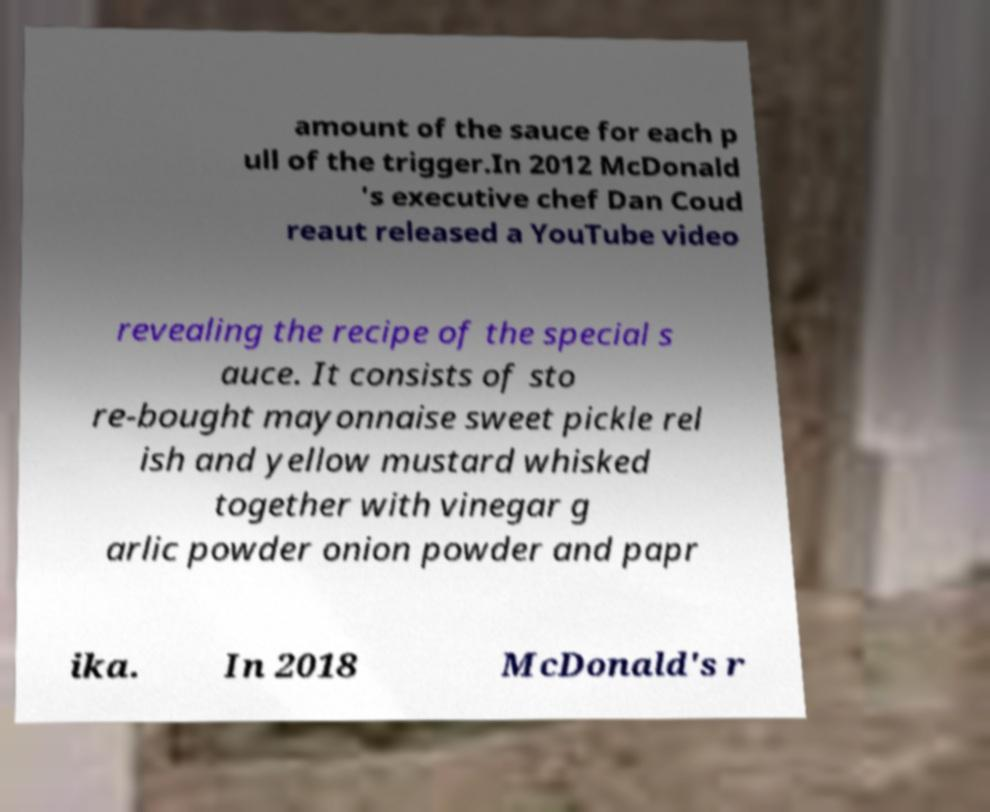Please identify and transcribe the text found in this image. amount of the sauce for each p ull of the trigger.In 2012 McDonald 's executive chef Dan Coud reaut released a YouTube video revealing the recipe of the special s auce. It consists of sto re-bought mayonnaise sweet pickle rel ish and yellow mustard whisked together with vinegar g arlic powder onion powder and papr ika. In 2018 McDonald's r 